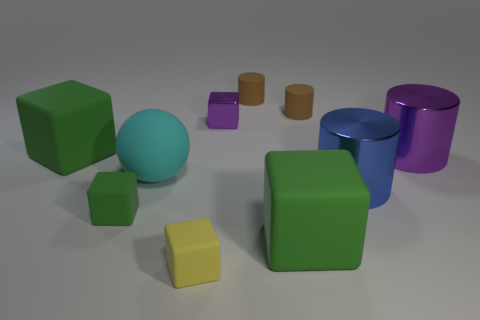What material is the green block that is the same size as the purple metal cube?
Give a very brief answer. Rubber. Are there any blue cylinders made of the same material as the cyan sphere?
Your answer should be very brief. No. There is a tiny matte thing to the left of the small matte block that is on the right side of the small object to the left of the matte sphere; what shape is it?
Offer a terse response. Cube. Is the size of the purple block the same as the shiny thing that is in front of the cyan rubber thing?
Your response must be concise. No. There is a tiny rubber thing that is both in front of the blue object and behind the small yellow matte object; what is its shape?
Ensure brevity in your answer.  Cube. What number of large objects are purple metallic objects or green things?
Your answer should be very brief. 3. Are there an equal number of small rubber cubes behind the small yellow cube and metal blocks that are behind the small shiny block?
Keep it short and to the point. No. How many other objects are the same color as the large rubber ball?
Make the answer very short. 0. Are there the same number of large matte objects in front of the tiny metallic object and large rubber objects?
Your answer should be very brief. Yes. Do the ball and the shiny block have the same size?
Offer a very short reply. No. 